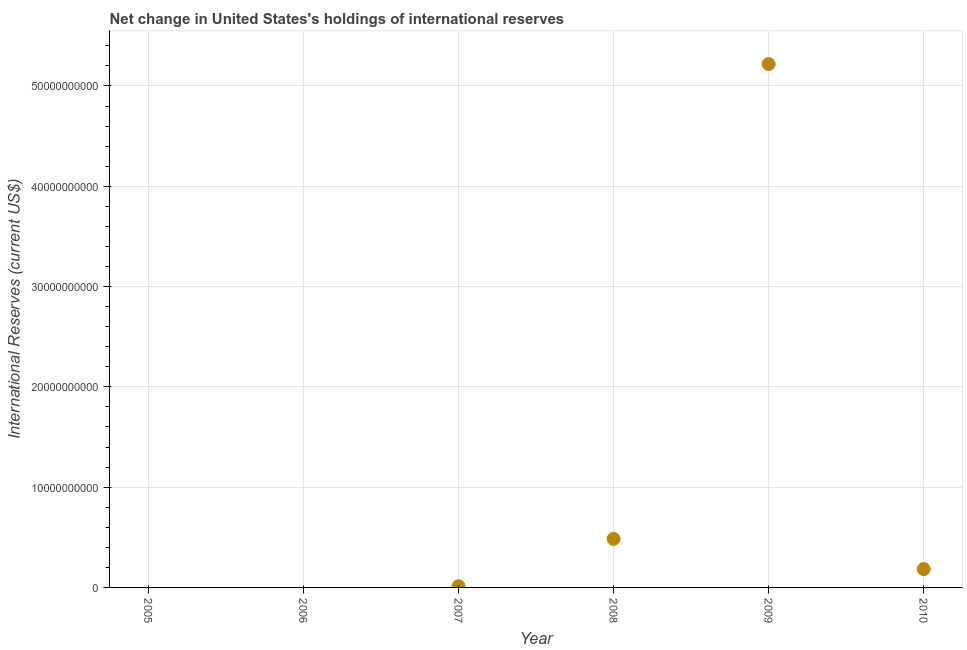Across all years, what is the maximum reserves and related items?
Offer a very short reply. 5.22e+1. Across all years, what is the minimum reserves and related items?
Your response must be concise. 0. What is the sum of the reserves and related items?
Keep it short and to the point. 5.90e+1. What is the difference between the reserves and related items in 2008 and 2009?
Keep it short and to the point. -4.73e+1. What is the average reserves and related items per year?
Provide a short and direct response. 9.83e+09. What is the median reserves and related items?
Keep it short and to the point. 9.75e+08. In how many years, is the reserves and related items greater than 12000000000 US$?
Give a very brief answer. 1. What is the ratio of the reserves and related items in 2007 to that in 2008?
Your answer should be very brief. 0.03. What is the difference between the highest and the second highest reserves and related items?
Offer a very short reply. 4.73e+1. Is the sum of the reserves and related items in 2009 and 2010 greater than the maximum reserves and related items across all years?
Keep it short and to the point. Yes. What is the difference between the highest and the lowest reserves and related items?
Make the answer very short. 5.22e+1. How many dotlines are there?
Keep it short and to the point. 1. How many years are there in the graph?
Your response must be concise. 6. Does the graph contain any zero values?
Give a very brief answer. Yes. Does the graph contain grids?
Give a very brief answer. Yes. What is the title of the graph?
Your answer should be very brief. Net change in United States's holdings of international reserves. What is the label or title of the Y-axis?
Offer a terse response. International Reserves (current US$). What is the International Reserves (current US$) in 2006?
Offer a very short reply. 0. What is the International Reserves (current US$) in 2007?
Provide a succinct answer. 1.24e+08. What is the International Reserves (current US$) in 2008?
Give a very brief answer. 4.84e+09. What is the International Reserves (current US$) in 2009?
Make the answer very short. 5.22e+1. What is the International Reserves (current US$) in 2010?
Your answer should be very brief. 1.83e+09. What is the difference between the International Reserves (current US$) in 2007 and 2008?
Your answer should be compact. -4.71e+09. What is the difference between the International Reserves (current US$) in 2007 and 2009?
Provide a short and direct response. -5.21e+1. What is the difference between the International Reserves (current US$) in 2007 and 2010?
Your answer should be compact. -1.70e+09. What is the difference between the International Reserves (current US$) in 2008 and 2009?
Your answer should be very brief. -4.73e+1. What is the difference between the International Reserves (current US$) in 2008 and 2010?
Keep it short and to the point. 3.01e+09. What is the difference between the International Reserves (current US$) in 2009 and 2010?
Your response must be concise. 5.04e+1. What is the ratio of the International Reserves (current US$) in 2007 to that in 2008?
Your response must be concise. 0.03. What is the ratio of the International Reserves (current US$) in 2007 to that in 2009?
Provide a short and direct response. 0. What is the ratio of the International Reserves (current US$) in 2007 to that in 2010?
Offer a terse response. 0.07. What is the ratio of the International Reserves (current US$) in 2008 to that in 2009?
Your answer should be very brief. 0.09. What is the ratio of the International Reserves (current US$) in 2008 to that in 2010?
Offer a very short reply. 2.65. What is the ratio of the International Reserves (current US$) in 2009 to that in 2010?
Provide a short and direct response. 28.59. 